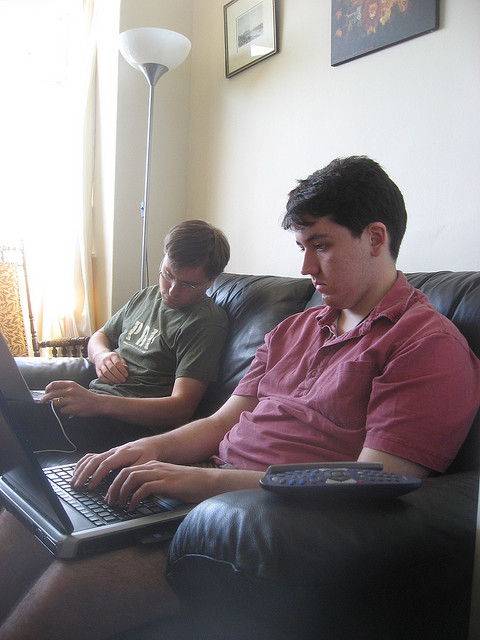Identify the text displayed in this image. PAY 